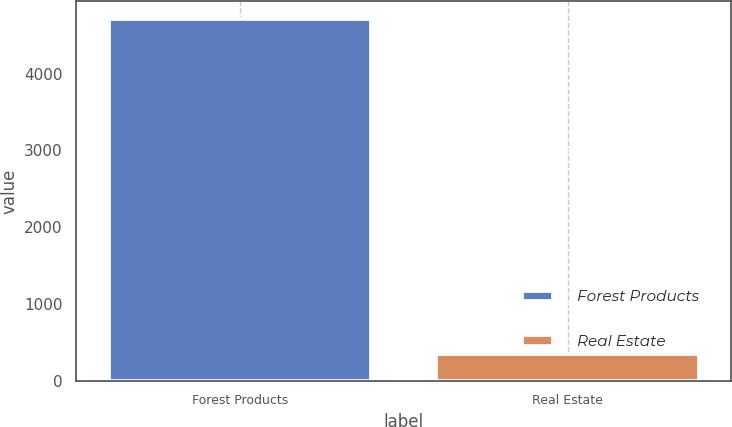Convert chart to OTSL. <chart><loc_0><loc_0><loc_500><loc_500><bar_chart><fcel>Forest Products<fcel>Real Estate<nl><fcel>4710<fcel>350<nl></chart> 